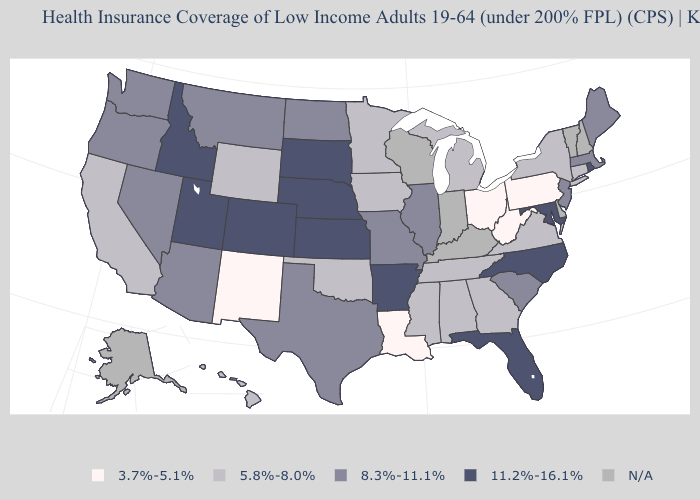What is the lowest value in the USA?
Quick response, please. 3.7%-5.1%. What is the highest value in the MidWest ?
Write a very short answer. 11.2%-16.1%. Does the first symbol in the legend represent the smallest category?
Answer briefly. Yes. How many symbols are there in the legend?
Quick response, please. 5. Name the states that have a value in the range 11.2%-16.1%?
Keep it brief. Arkansas, Colorado, Florida, Idaho, Kansas, Maryland, Nebraska, North Carolina, Rhode Island, South Dakota, Utah. Name the states that have a value in the range 8.3%-11.1%?
Answer briefly. Arizona, Illinois, Maine, Massachusetts, Missouri, Montana, Nevada, New Jersey, North Dakota, Oregon, South Carolina, Texas, Washington. Which states have the lowest value in the USA?
Concise answer only. Louisiana, New Mexico, Ohio, Pennsylvania, West Virginia. Does the first symbol in the legend represent the smallest category?
Give a very brief answer. Yes. Name the states that have a value in the range 3.7%-5.1%?
Quick response, please. Louisiana, New Mexico, Ohio, Pennsylvania, West Virginia. Which states have the highest value in the USA?
Keep it brief. Arkansas, Colorado, Florida, Idaho, Kansas, Maryland, Nebraska, North Carolina, Rhode Island, South Dakota, Utah. Which states have the highest value in the USA?
Give a very brief answer. Arkansas, Colorado, Florida, Idaho, Kansas, Maryland, Nebraska, North Carolina, Rhode Island, South Dakota, Utah. Name the states that have a value in the range N/A?
Be succinct. Alaska, Delaware, Indiana, Kentucky, New Hampshire, Vermont, Wisconsin. What is the value of Rhode Island?
Give a very brief answer. 11.2%-16.1%. 